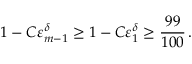Convert formula to latex. <formula><loc_0><loc_0><loc_500><loc_500>1 - C \varepsilon _ { m - 1 } ^ { \delta } \geq 1 - C \varepsilon _ { 1 } ^ { \delta } \geq \frac { 9 9 } { 1 0 0 } \, .</formula> 